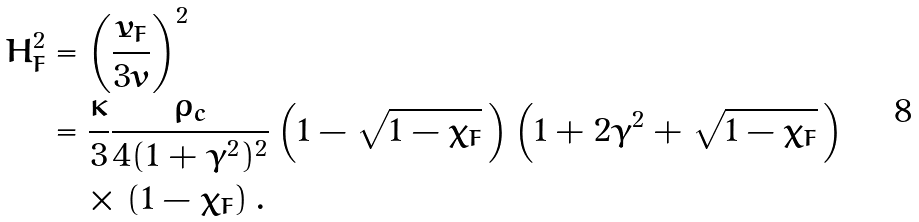<formula> <loc_0><loc_0><loc_500><loc_500>H _ { F } ^ { 2 } & = \left ( \frac { \dot { v } _ { F } } { 3 v } \right ) ^ { 2 } \\ & = \frac { \kappa } { 3 } \frac { \rho _ { c } } { 4 ( 1 + \gamma ^ { 2 } ) ^ { 2 } } \left ( 1 - \sqrt { 1 - \chi _ { F } } \, \right ) \left ( 1 + 2 \gamma ^ { 2 } + \sqrt { 1 - \chi _ { F } } \, \right ) \\ & \quad \times \left ( 1 - \chi _ { F } \right ) .</formula> 